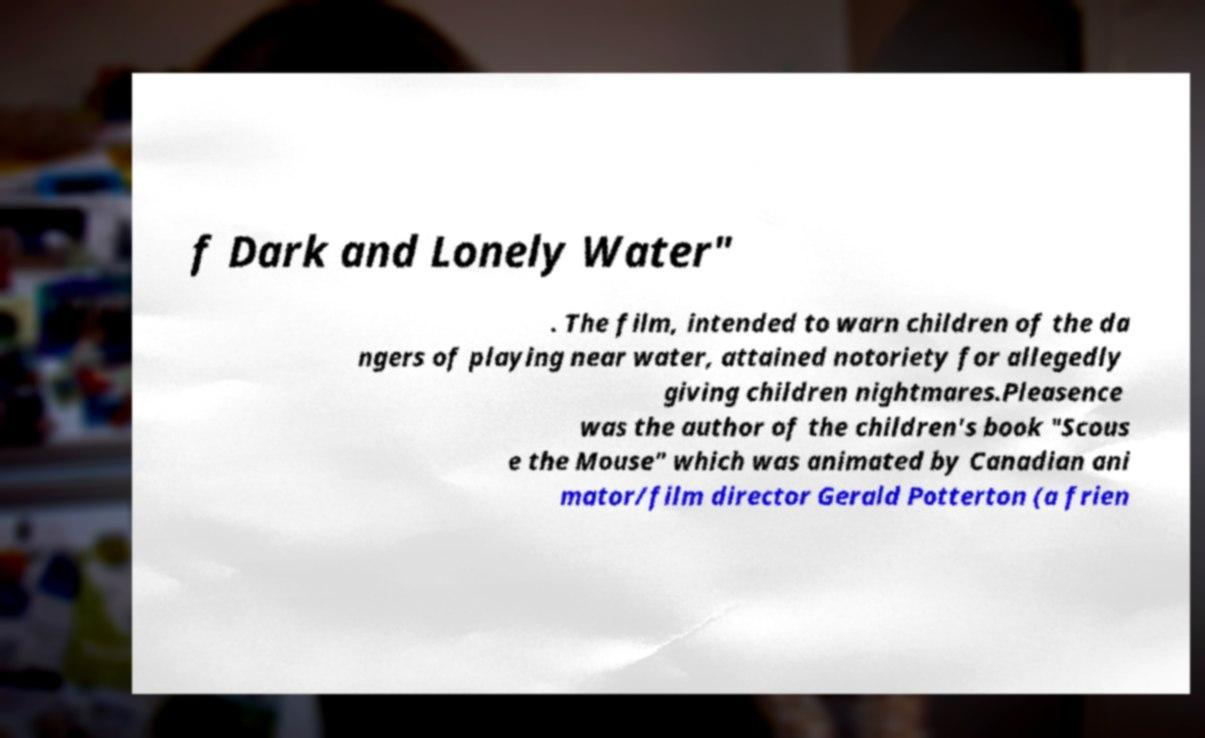There's text embedded in this image that I need extracted. Can you transcribe it verbatim? f Dark and Lonely Water" . The film, intended to warn children of the da ngers of playing near water, attained notoriety for allegedly giving children nightmares.Pleasence was the author of the children's book "Scous e the Mouse" which was animated by Canadian ani mator/film director Gerald Potterton (a frien 